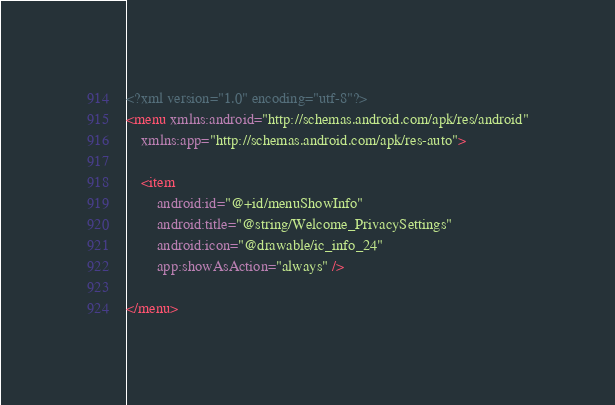<code> <loc_0><loc_0><loc_500><loc_500><_XML_><?xml version="1.0" encoding="utf-8"?>
<menu xmlns:android="http://schemas.android.com/apk/res/android"
    xmlns:app="http://schemas.android.com/apk/res-auto">

    <item
        android:id="@+id/menuShowInfo"
        android:title="@string/Welcome_PrivacySettings"
        android:icon="@drawable/ic_info_24"
        app:showAsAction="always" />

</menu>
</code> 